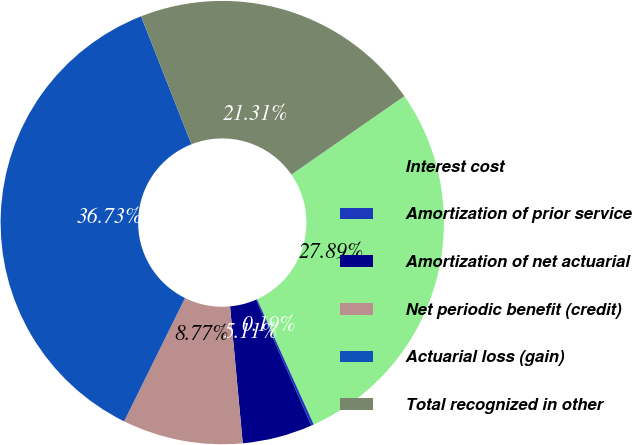Convert chart to OTSL. <chart><loc_0><loc_0><loc_500><loc_500><pie_chart><fcel>Interest cost<fcel>Amortization of prior service<fcel>Amortization of net actuarial<fcel>Net periodic benefit (credit)<fcel>Actuarial loss (gain)<fcel>Total recognized in other<nl><fcel>27.89%<fcel>0.19%<fcel>5.11%<fcel>8.77%<fcel>36.73%<fcel>21.31%<nl></chart> 